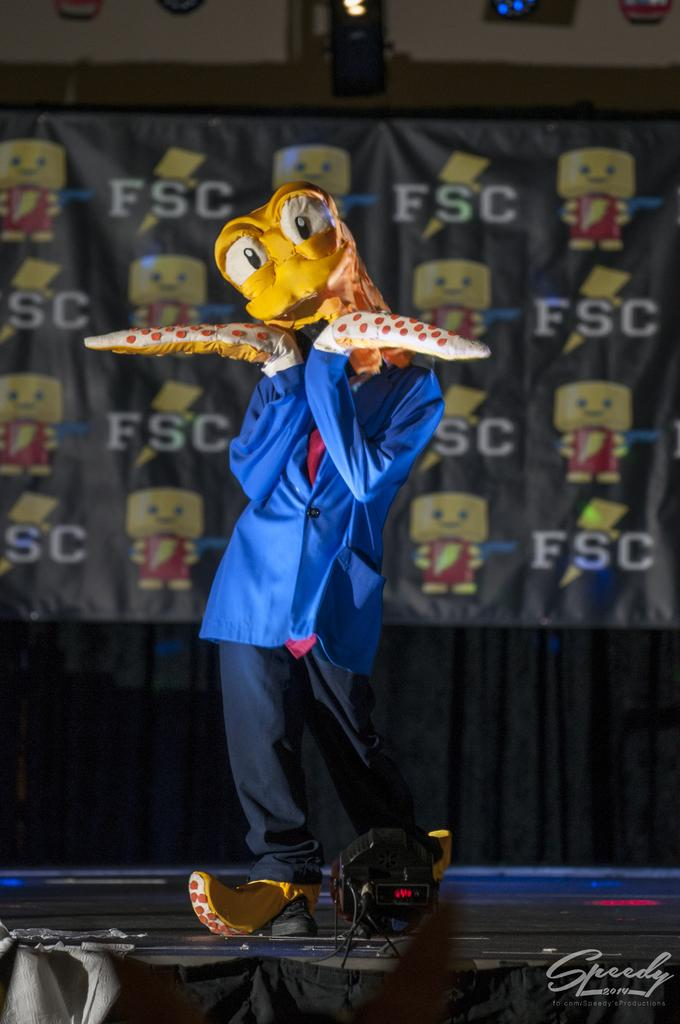Who or what is present in the image? There is a person in the image. What can be seen in the background of the image? There is a curtain in the background of the image. What type of bean is being used as a prop in the image? There is no bean present in the image. 